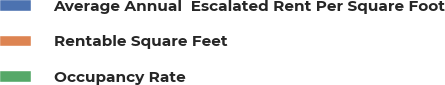<chart> <loc_0><loc_0><loc_500><loc_500><pie_chart><fcel>Average Annual  Escalated Rent Per Square Foot<fcel>Rentable Square Feet<fcel>Occupancy Rate<nl><fcel>100.0%<fcel>0.0%<fcel>0.0%<nl></chart> 